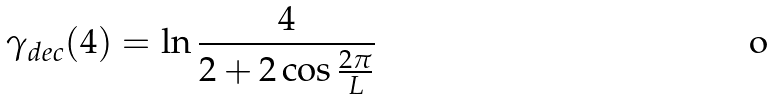<formula> <loc_0><loc_0><loc_500><loc_500>\gamma _ { d e c } ( 4 ) = \ln \frac { 4 } { 2 + 2 \cos \frac { 2 \pi } { L } }</formula> 